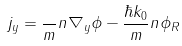<formula> <loc_0><loc_0><loc_500><loc_500>j _ { y } = \frac { } { m } n \nabla _ { y } \phi - \frac { \hbar { k } _ { 0 } } { m } n \phi _ { R }</formula> 